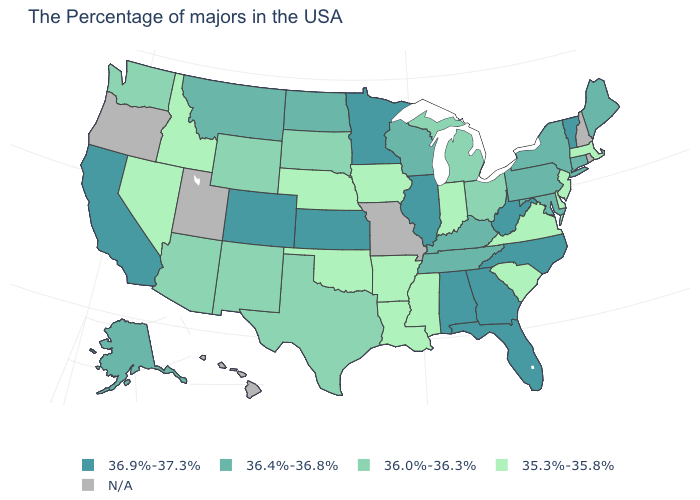Does the map have missing data?
Short answer required. Yes. What is the value of New Hampshire?
Give a very brief answer. N/A. Which states have the lowest value in the USA?
Answer briefly. Massachusetts, New Jersey, Delaware, Virginia, South Carolina, Indiana, Mississippi, Louisiana, Arkansas, Iowa, Nebraska, Oklahoma, Idaho, Nevada. What is the value of Oklahoma?
Give a very brief answer. 35.3%-35.8%. Name the states that have a value in the range 35.3%-35.8%?
Quick response, please. Massachusetts, New Jersey, Delaware, Virginia, South Carolina, Indiana, Mississippi, Louisiana, Arkansas, Iowa, Nebraska, Oklahoma, Idaho, Nevada. Which states have the lowest value in the USA?
Short answer required. Massachusetts, New Jersey, Delaware, Virginia, South Carolina, Indiana, Mississippi, Louisiana, Arkansas, Iowa, Nebraska, Oklahoma, Idaho, Nevada. Does the map have missing data?
Give a very brief answer. Yes. What is the value of California?
Write a very short answer. 36.9%-37.3%. Among the states that border Indiana , does Ohio have the highest value?
Write a very short answer. No. Which states hav the highest value in the West?
Answer briefly. Colorado, California. What is the lowest value in the MidWest?
Write a very short answer. 35.3%-35.8%. Name the states that have a value in the range 36.4%-36.8%?
Quick response, please. Maine, Connecticut, New York, Maryland, Pennsylvania, Kentucky, Tennessee, Wisconsin, North Dakota, Montana, Alaska. Which states have the lowest value in the USA?
Give a very brief answer. Massachusetts, New Jersey, Delaware, Virginia, South Carolina, Indiana, Mississippi, Louisiana, Arkansas, Iowa, Nebraska, Oklahoma, Idaho, Nevada. Name the states that have a value in the range 36.4%-36.8%?
Keep it brief. Maine, Connecticut, New York, Maryland, Pennsylvania, Kentucky, Tennessee, Wisconsin, North Dakota, Montana, Alaska. What is the lowest value in the USA?
Quick response, please. 35.3%-35.8%. 